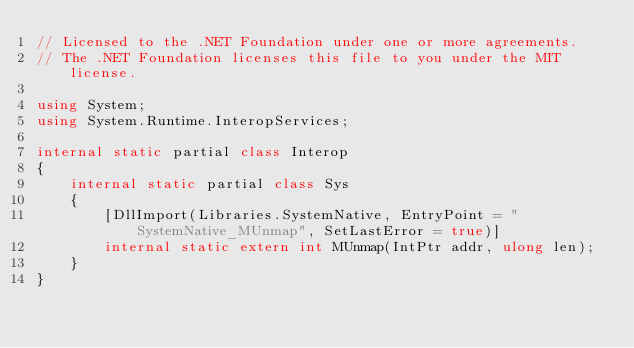Convert code to text. <code><loc_0><loc_0><loc_500><loc_500><_C#_>// Licensed to the .NET Foundation under one or more agreements.
// The .NET Foundation licenses this file to you under the MIT license.

using System;
using System.Runtime.InteropServices;

internal static partial class Interop
{
    internal static partial class Sys
    {
        [DllImport(Libraries.SystemNative, EntryPoint = "SystemNative_MUnmap", SetLastError = true)]
        internal static extern int MUnmap(IntPtr addr, ulong len);
    }
}
</code> 